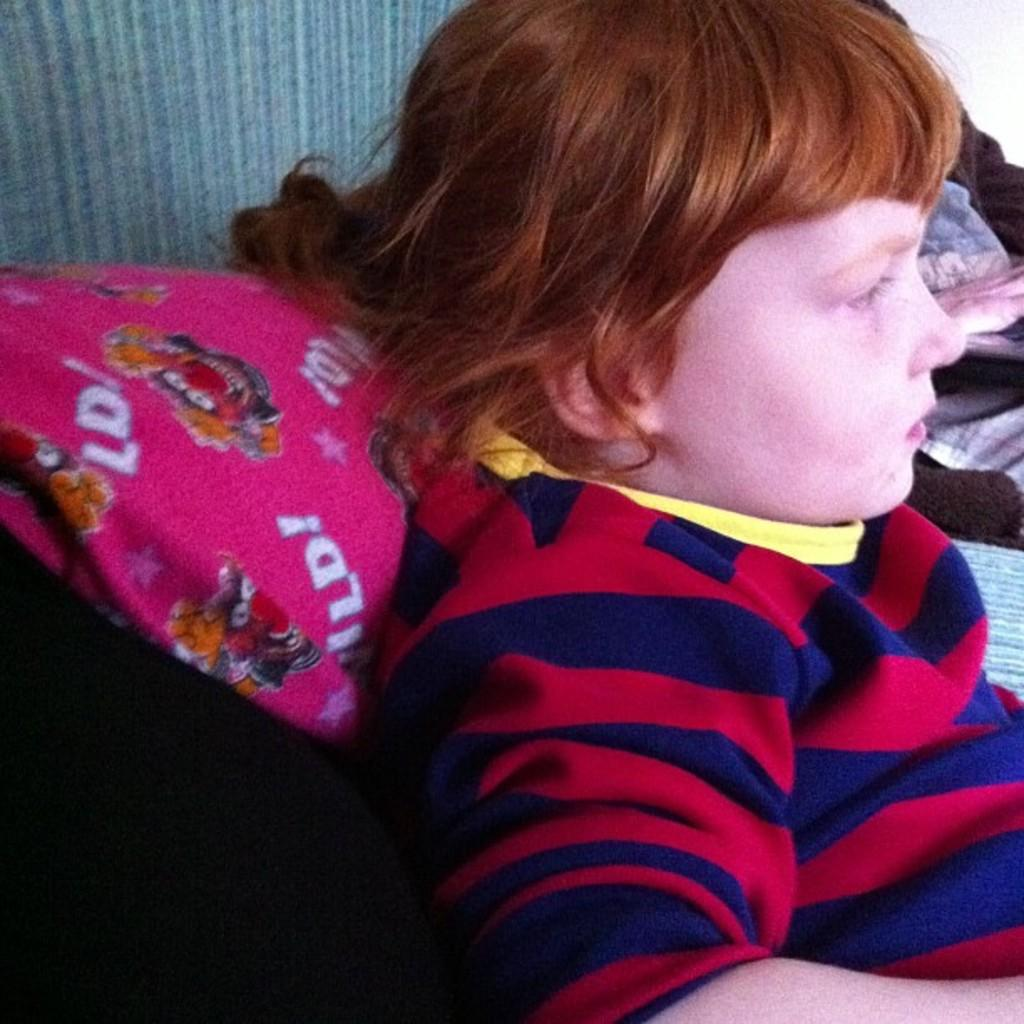What is the main subject of the picture? The main subject of the picture is a kid. What is the kid doing in the picture? The kid is laying on some tool. What is supporting the kid's neck in the picture? There is a pink pillow behind the kid's neck. What is the kid wearing in the picture? The kid is wearing a red and blue shirt. How many pizzas are visible in the picture? There are no pizzas present in the picture. What type of sugar is being used to sweeten the kid's shirt? There is no sugar mentioned or visible in the picture; the kid is wearing a red and blue shirt. 